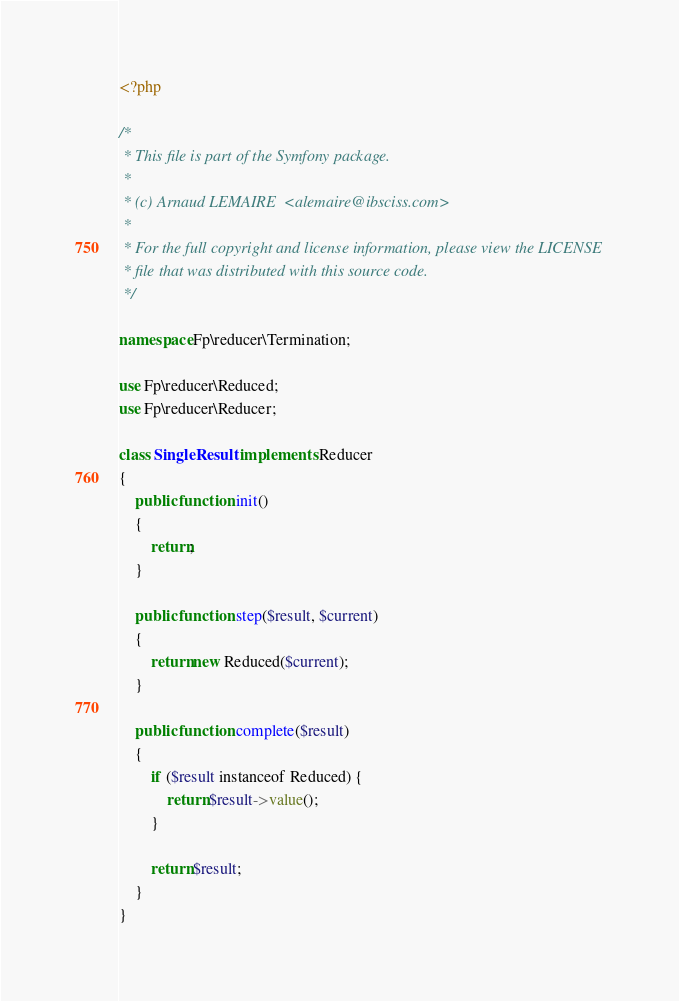<code> <loc_0><loc_0><loc_500><loc_500><_PHP_><?php

/*
 * This file is part of the Symfony package.
 *
 * (c) Arnaud LEMAIRE  <alemaire@ibsciss.com>
 *
 * For the full copyright and license information, please view the LICENSE
 * file that was distributed with this source code.
 */

namespace Fp\reducer\Termination;

use Fp\reducer\Reduced;
use Fp\reducer\Reducer;

class SingleResult implements Reducer
{
    public function init()
    {
        return;
    }

    public function step($result, $current)
    {
        return new Reduced($current);
    }

    public function complete($result)
    {
        if ($result instanceof Reduced) {
            return $result->value();
        }

        return $result;
    }
}
</code> 